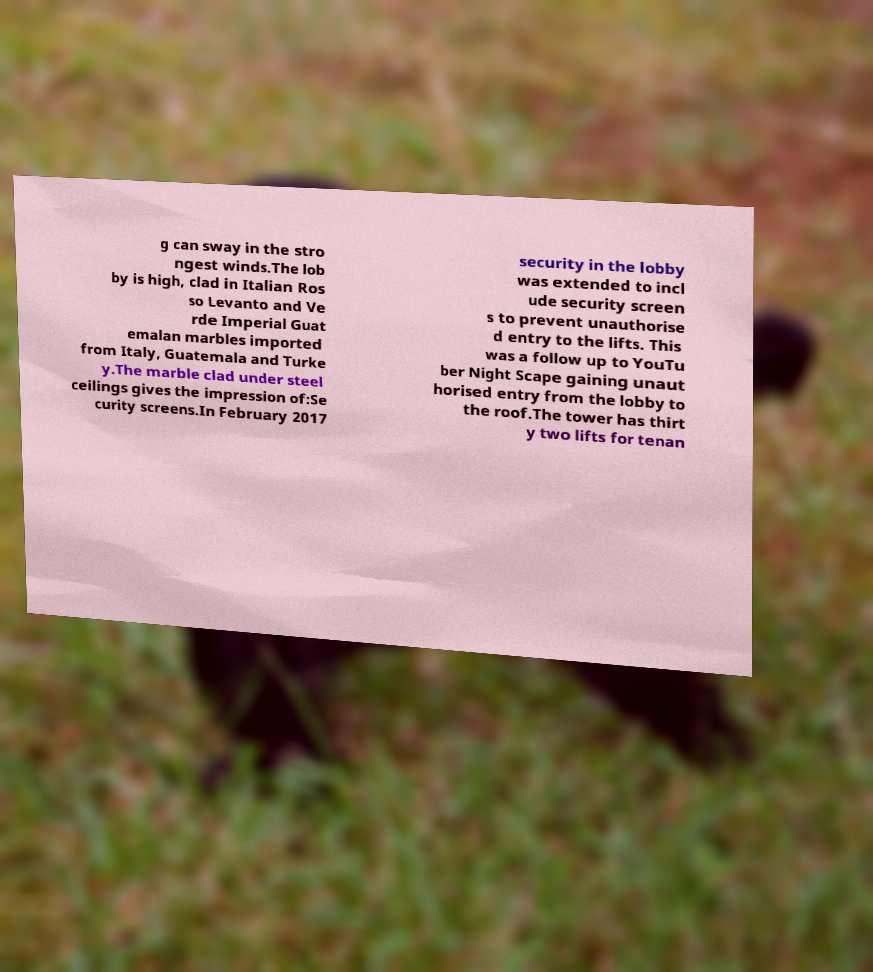Could you assist in decoding the text presented in this image and type it out clearly? g can sway in the stro ngest winds.The lob by is high, clad in Italian Ros so Levanto and Ve rde Imperial Guat emalan marbles imported from Italy, Guatemala and Turke y.The marble clad under steel ceilings gives the impression of:Se curity screens.In February 2017 security in the lobby was extended to incl ude security screen s to prevent unauthorise d entry to the lifts. This was a follow up to YouTu ber Night Scape gaining unaut horised entry from the lobby to the roof.The tower has thirt y two lifts for tenan 